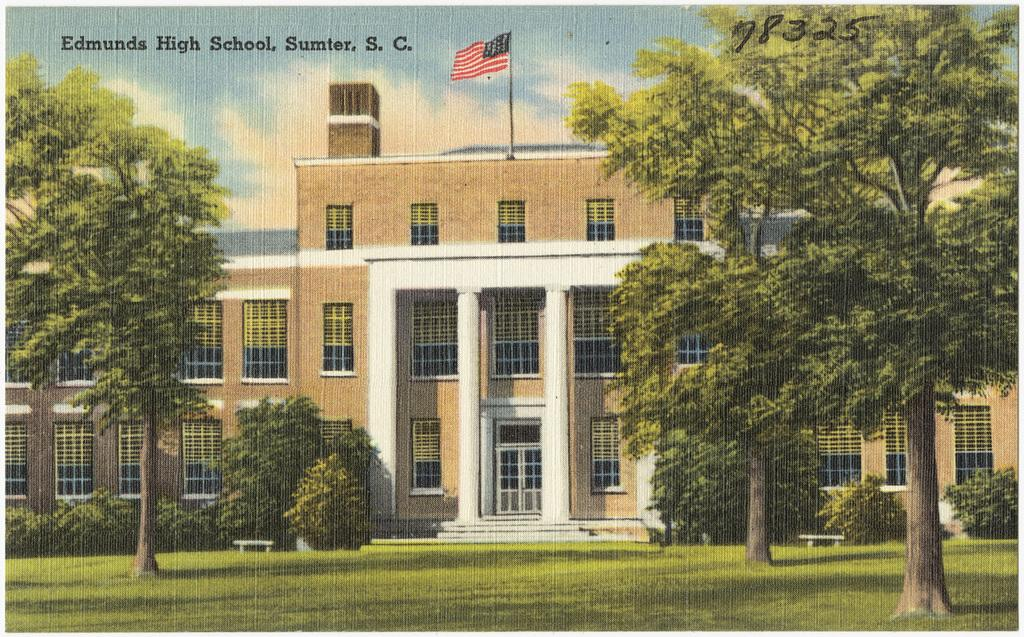What is the main subject of the poster in the image? The poster contains images of grass, plants, trees, buildings, benches, a flag pole, and the sky. What type of vegetation is depicted on the poster? The poster contains images of grass, plants, and trees. Are there any man-made structures depicted on the poster? Yes, the poster contains images of buildings. What other elements can be seen on the poster besides the images? There is text and a number at the top of the image. How does the expert use the pen to write on the poster? There is no expert or pen present in the image; the poster only contains images and text. 